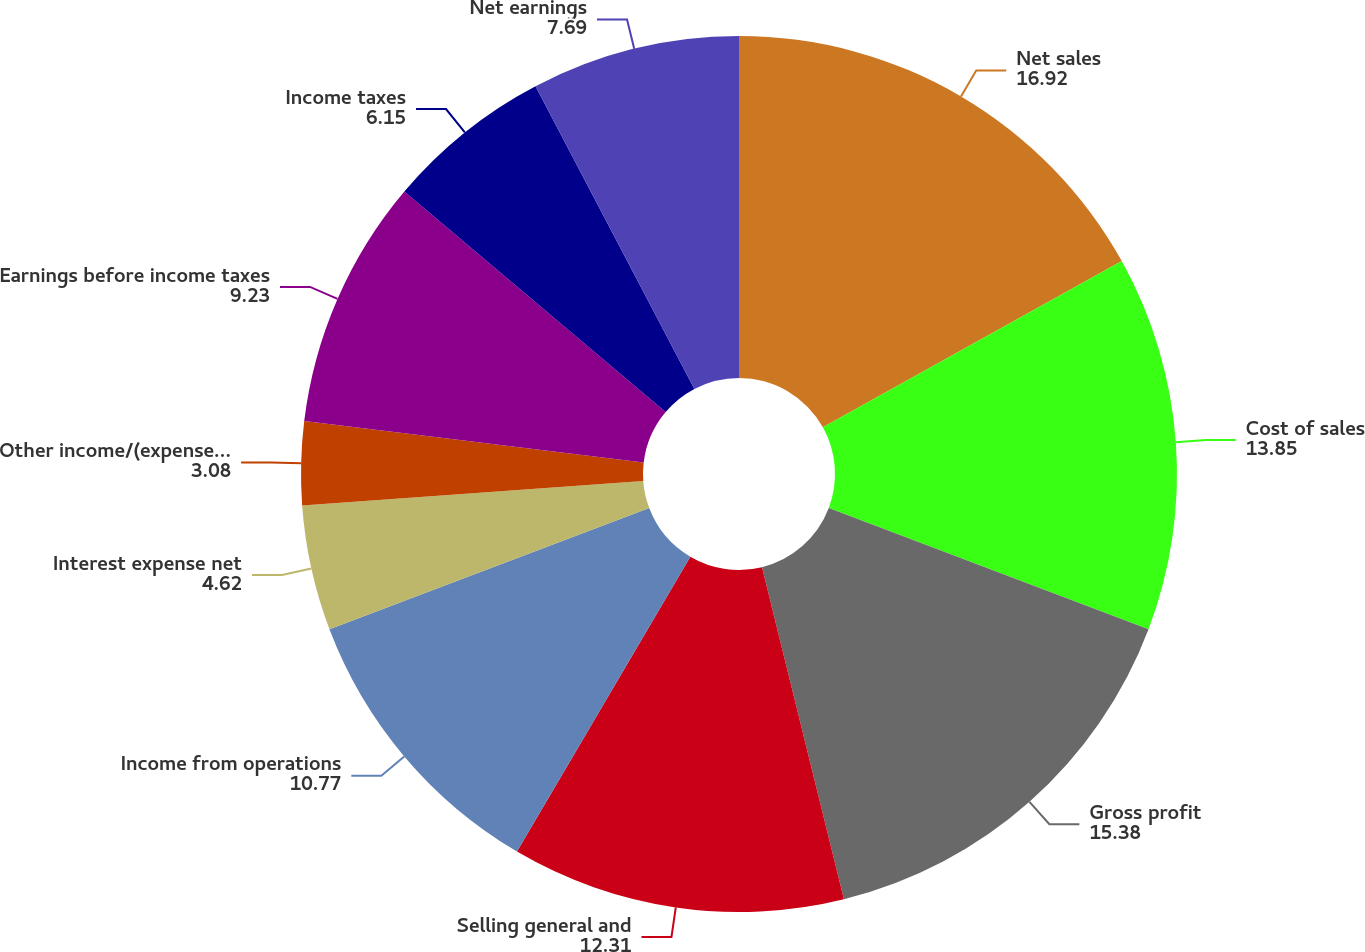Convert chart to OTSL. <chart><loc_0><loc_0><loc_500><loc_500><pie_chart><fcel>Net sales<fcel>Cost of sales<fcel>Gross profit<fcel>Selling general and<fcel>Income from operations<fcel>Interest expense net<fcel>Other income/(expense) net<fcel>Earnings before income taxes<fcel>Income taxes<fcel>Net earnings<nl><fcel>16.92%<fcel>13.85%<fcel>15.38%<fcel>12.31%<fcel>10.77%<fcel>4.62%<fcel>3.08%<fcel>9.23%<fcel>6.15%<fcel>7.69%<nl></chart> 